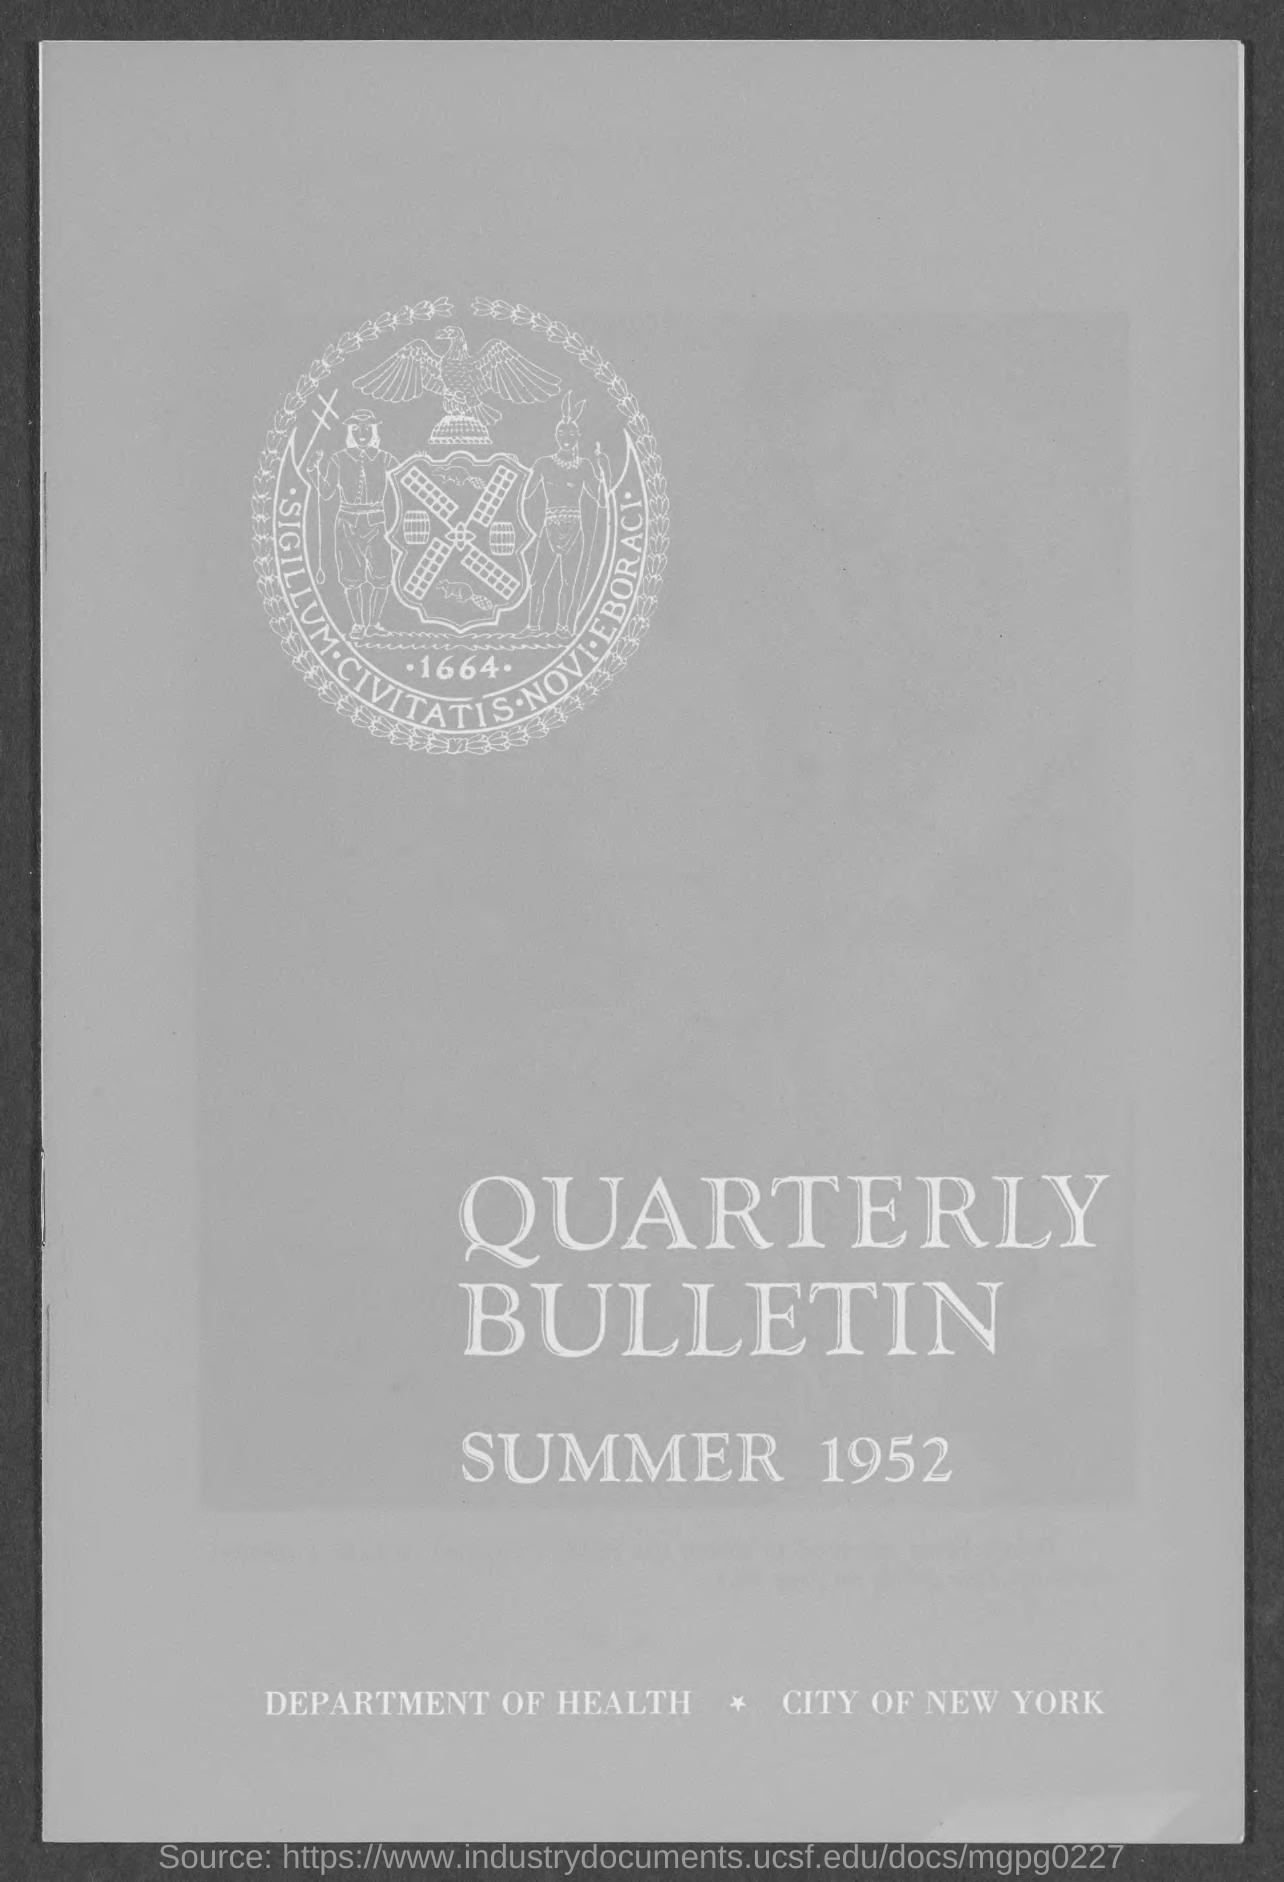What is the title of document?
Keep it short and to the point. Quarterly Bulletin. What is the year mentioned in the document?
Give a very brief answer. 1952. Which city is mentioned in the document?
Offer a terse response. NEW YORK. 